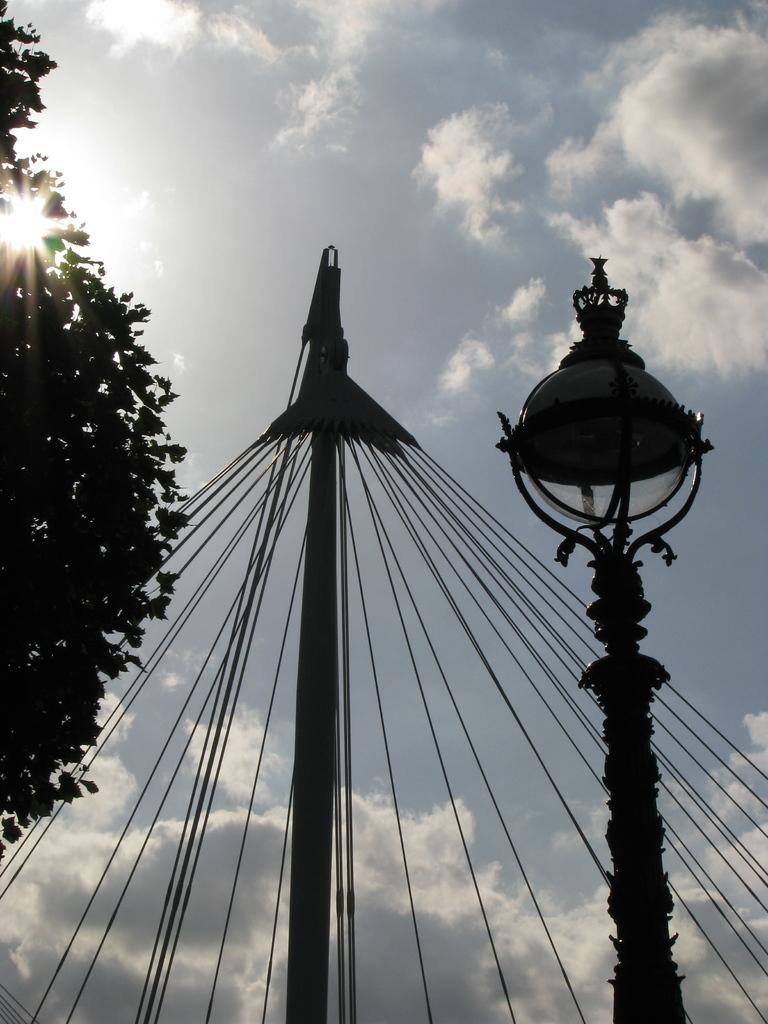What is the main object in the image? There is a metal pole in the image. What is connected to the metal pole? There are wires attached to the pole. What natural element is present in the image? There is a tree in the image. What can be seen in the background of the image? The sky is visible in the background of the image. What celestial body is observable in the sky? The sun is observable in the sky. How many girls are playing quietly near the metal pole in the image? There are no girls present in the image, and therefore no such activity can be observed. 